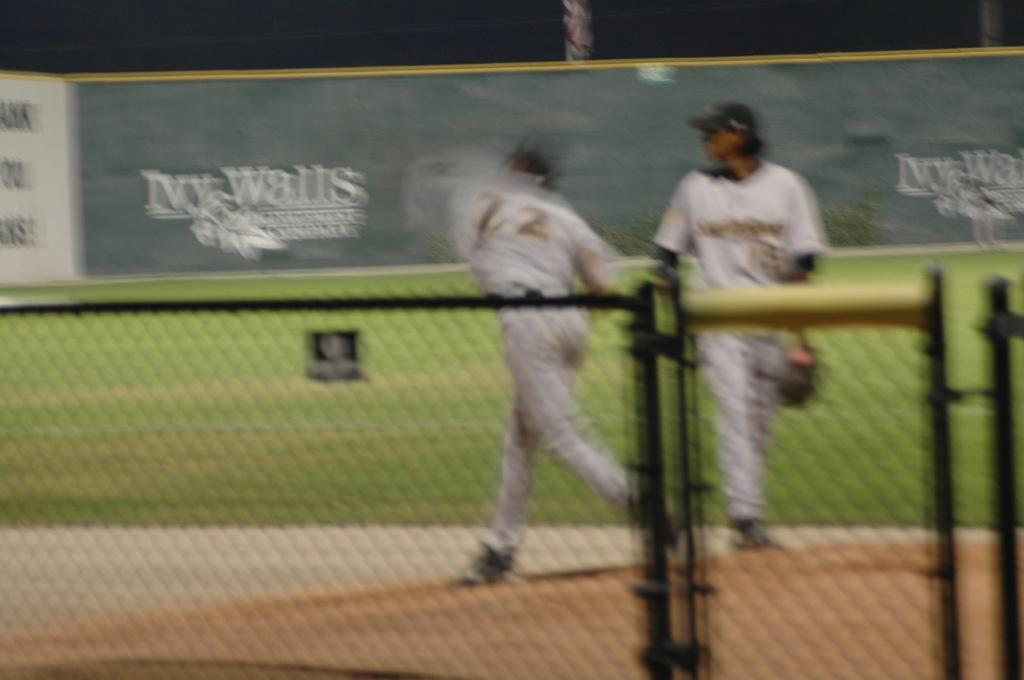How many people are in the image? There are two persons in the image. What is located in the foreground of the image? There is a fencing in the foreground. What can be seen behind the persons in the image? There is an advertising board visible behind the persons. What type of surface is present in the image? Grass is present in the image. What is written on the advertising board? There is text on the advertising board. Can you tell me how many cherries are being exchanged between the two persons in the image? There are no cherries present in the image, nor is there any exchange taking place between the two persons. 